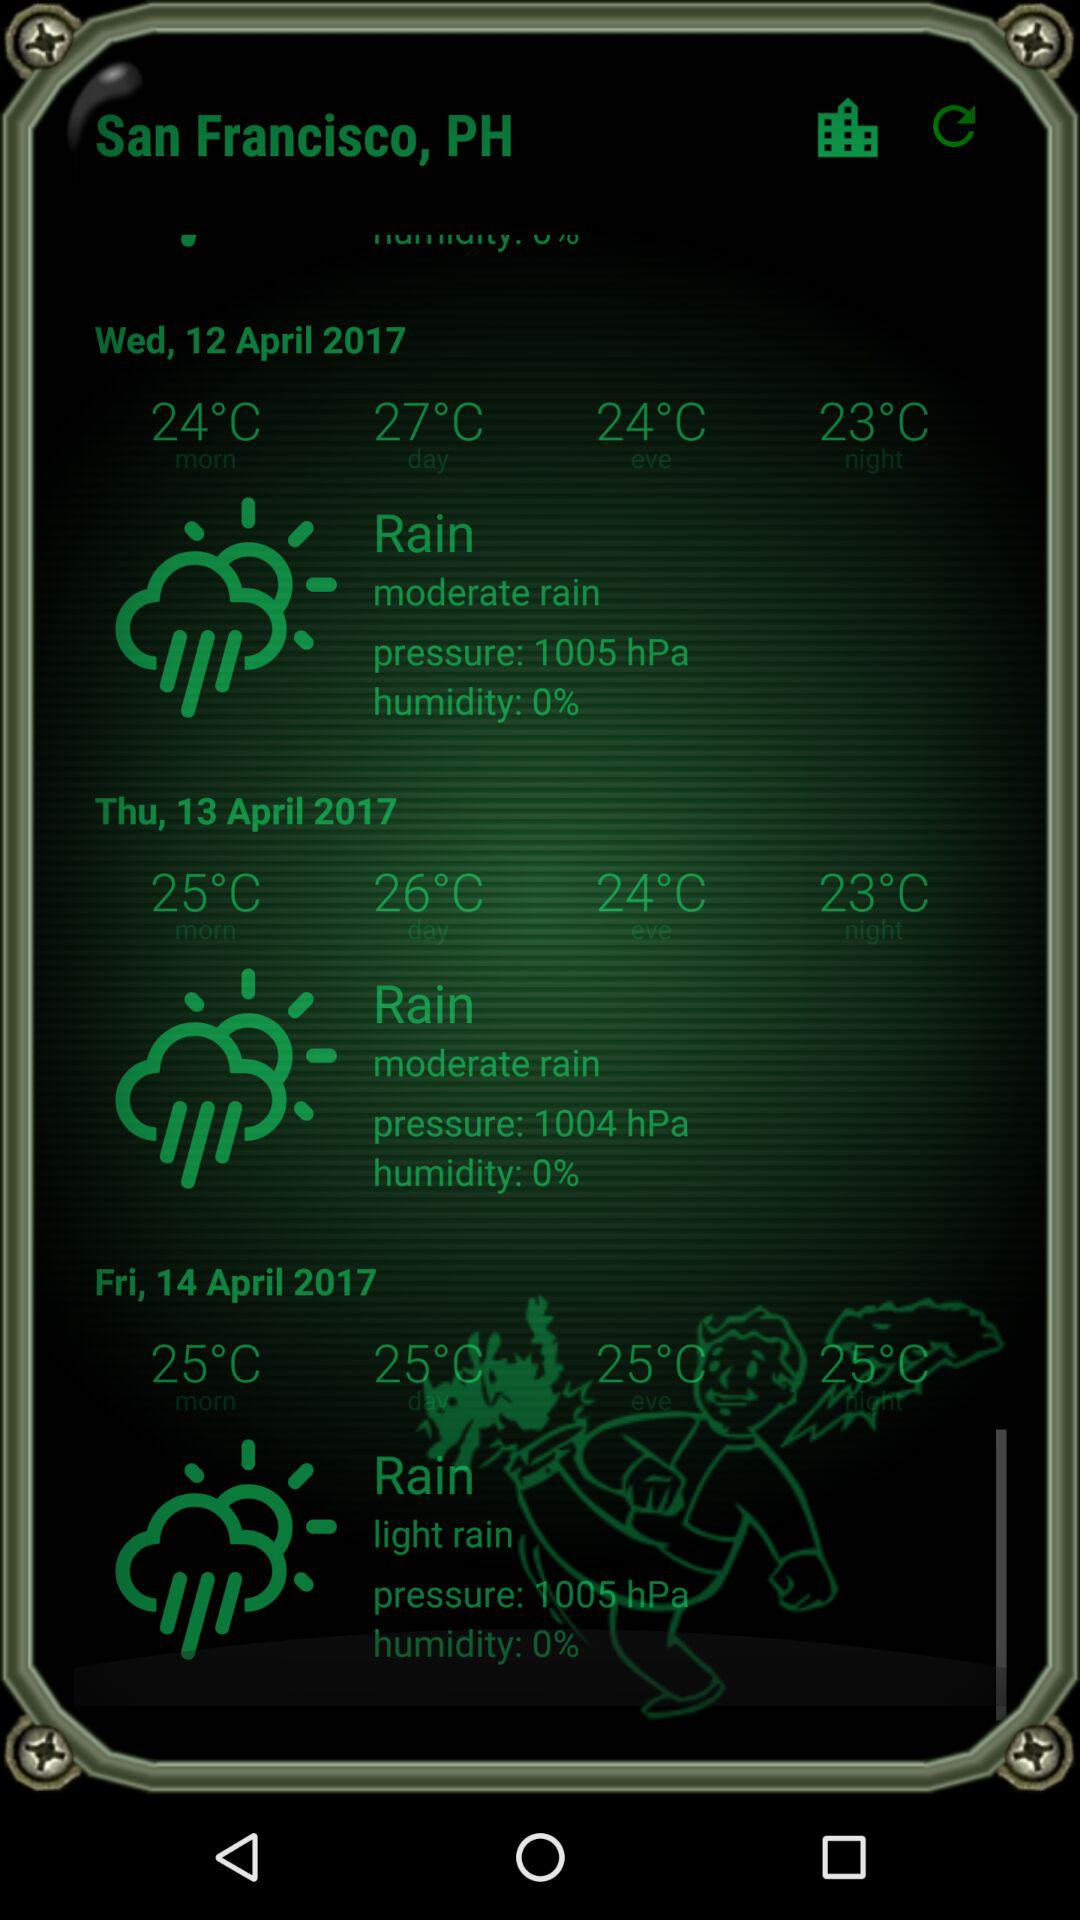How much higher is the temperature on Wednesday than on Thursday?
Answer the question using a single word or phrase. 1°C 